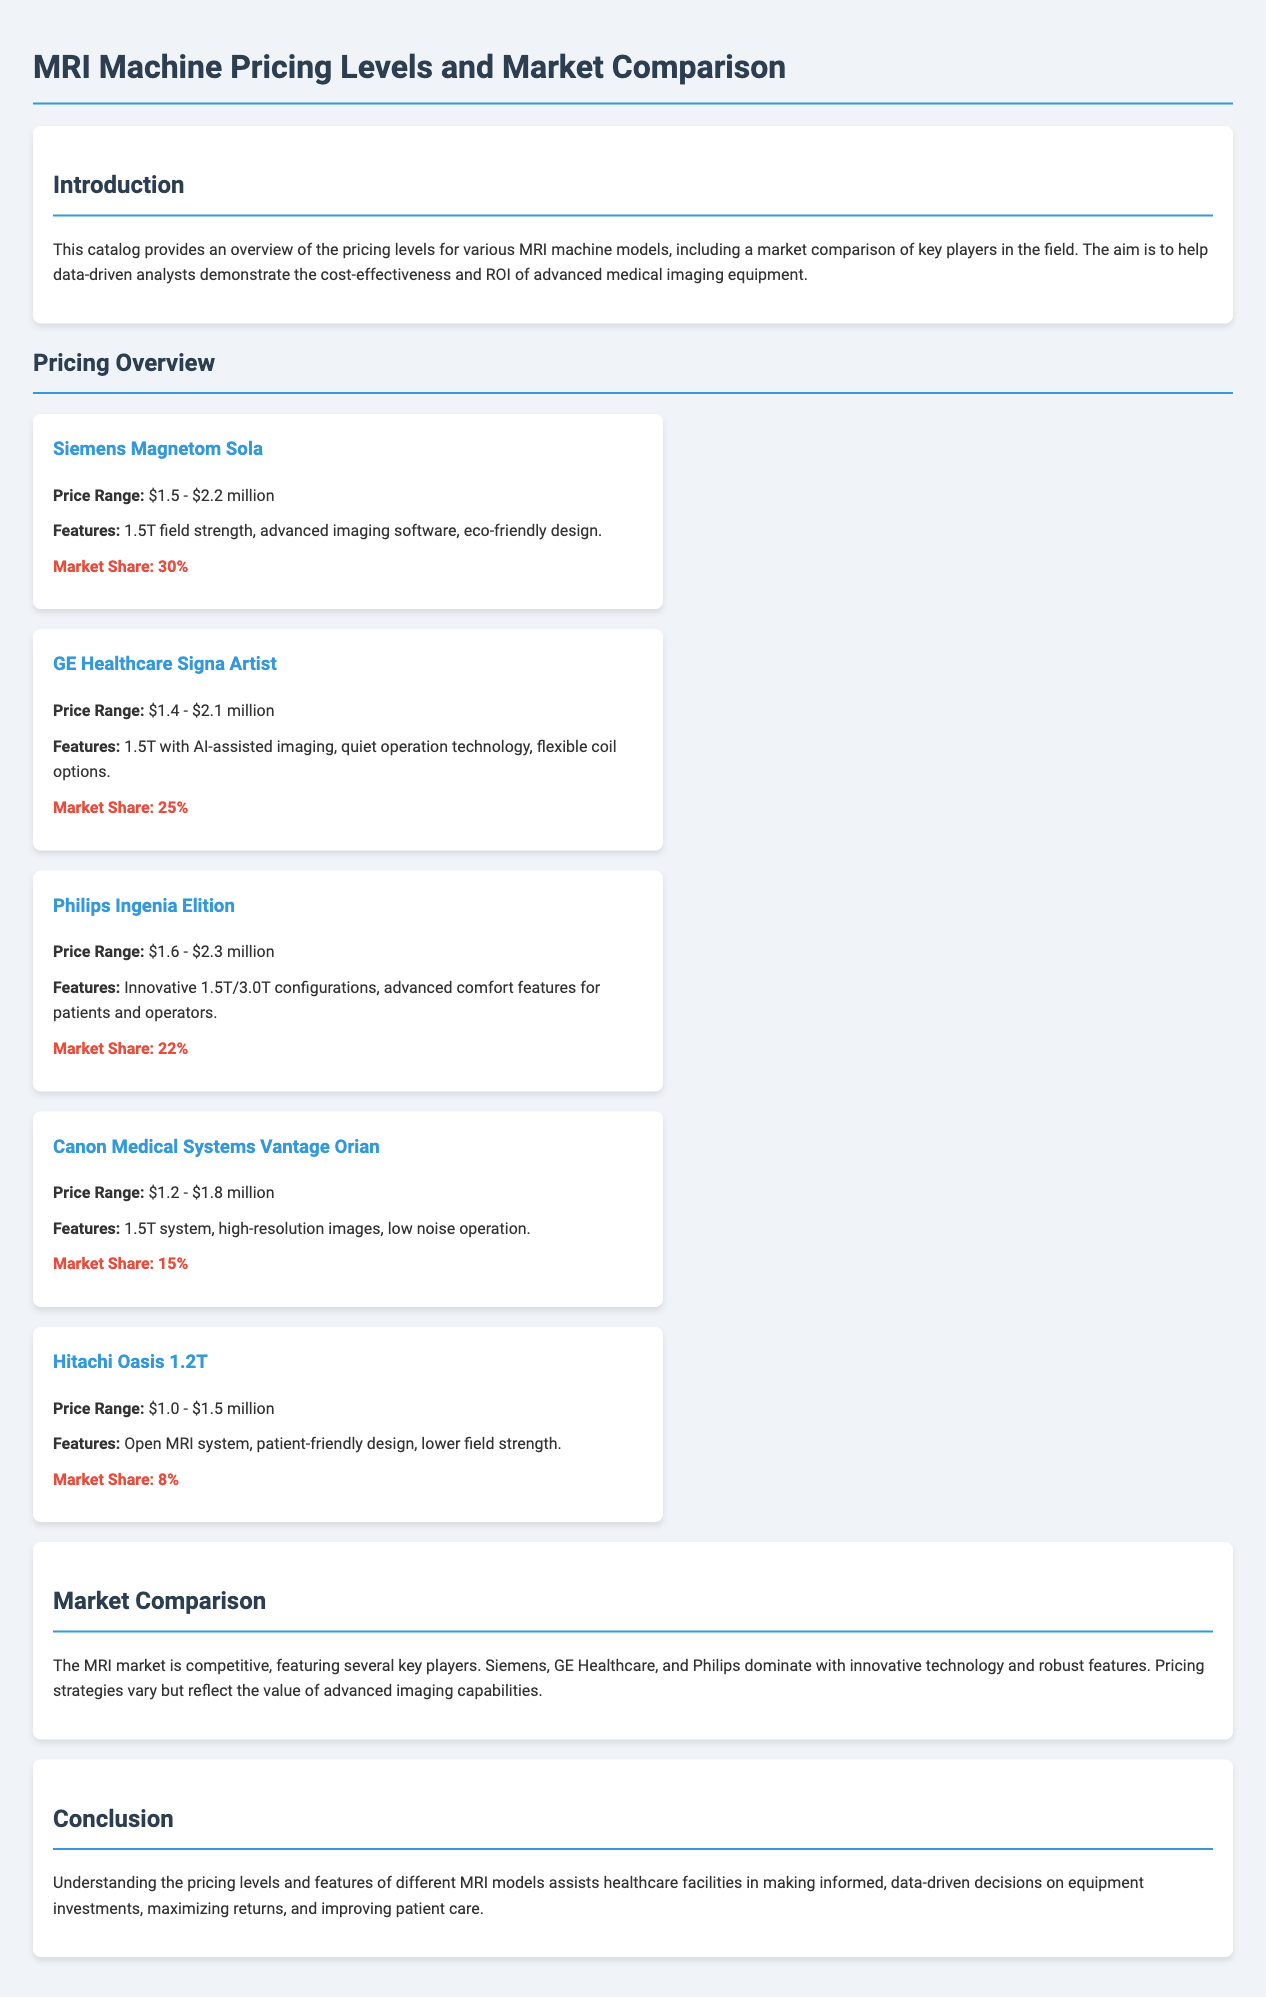what is the price range of the Siemens Magnetom Sola? The pricing overview provides specific price ranges for each model, showing that the Siemens Magnetom Sola ranges from $1.5 million to $2.2 million.
Answer: $1.5 - $2.2 million which MRI machine has the highest market share? The market share details indicate that the Siemens Magnetom Sola has the highest market share at 30%.
Answer: 30% what features does the GE Healthcare Signa Artist offer? The document lists the features for each model, revealing that the GE Healthcare Signa Artist offers AI-assisted imaging, quiet operation technology, and flexible coil options.
Answer: AI-assisted imaging, quiet operation technology, flexible coil options how much does the Canon Medical Systems Vantage Orian cost at minimum? The pricing overview specifies the lowest price of the Canon Medical Systems Vantage Orian, which is $1.2 million.
Answer: $1.2 million is the Hitachi Oasis an open MRI system? The features described for the Hitachi Oasis 1.2T confirm that it is indeed an open MRI system, suitable for patient-friendly designs.
Answer: Yes which company offers an MRI machine with a price range starting at $1.0 million? The document states that the Hitachi Oasis 1.2T has a price range beginning at $1.0 million.
Answer: Hitachi what is the market share of the Philips Ingenia Elition? According to the market share information, the Philips Ingenia Elition holds a 22% market share.
Answer: 22% what kind of technology does the Philips Ingenia Elition highlight? The features section reveals that the Philips Ingenia Elition highlights innovative 1.5T/3.0T configurations, enhancing comfort for both patients and operators.
Answer: Innovative 1.5T/3.0T configurations what major aspect differentiates GE Healthcare and Philips in terms of features? The comparison implies that GE Healthcare emphasizes AI-assisted imaging technology while Philips focuses on comfort features for patients; this shows competitive technological advancements between the two.
Answer: AI-assisted imaging vs. comfort features 